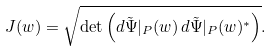Convert formula to latex. <formula><loc_0><loc_0><loc_500><loc_500>J ( w ) = \sqrt { \det \left ( d \tilde { \Psi } | _ { P } ( w ) \, d \tilde { \Psi } | _ { P } ( w ) ^ { * } \right ) } .</formula> 